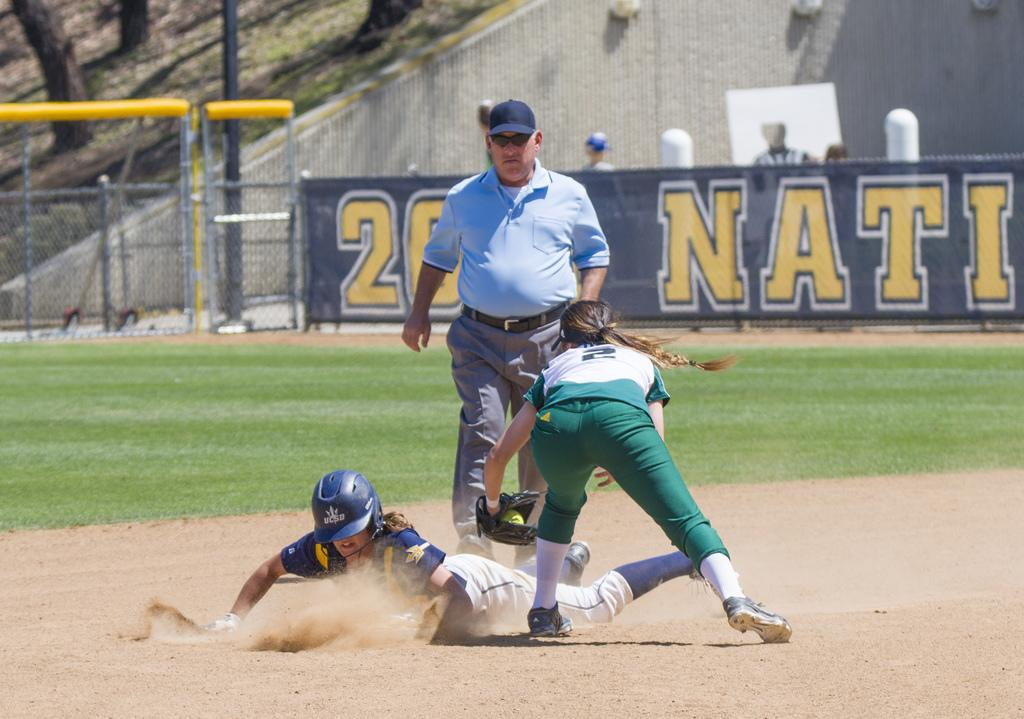<image>
Share a concise interpretation of the image provided. A softball player numbered 2 trying to stop a player at the base. 